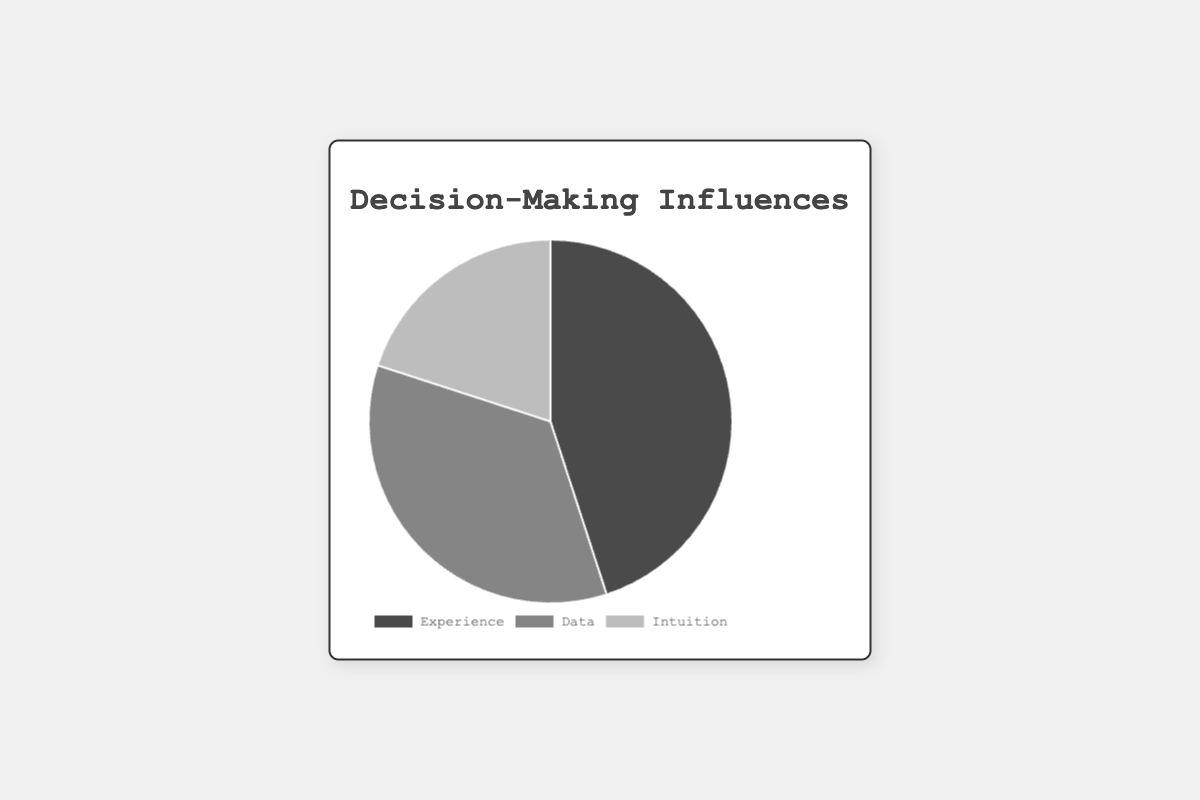What percentage of decision-making is influenced by intuition? The pie chart shows that the "Intuition" slice occupies 20% of the pie chart.
Answer: 20% Which influence has the largest proportion in decision-making? By looking at the proportions in the pie chart, "Experience" has the largest slice, indicating it has the largest proportion at 45%.
Answer: Experience How much more does experience influence decision-making compared to data? "Experience" influences decision-making by 45%, while "Data" influences it by 35%. The difference can be calculated as 45% - 35% = 10%.
Answer: 10% Which category influences decision-making the least? The smallest slice in the pie chart represents the "Intuition" category, which occupies 20% of the chart.
Answer: Intuition Is the proportion of decisions influenced by data more than double the proportion influenced by intuition? The proportion of intuition is 20%, and twice that is 40%. The data influence is 35%, which is less than 40%, so it’s not more than double.
Answer: No What are the combined percentages of experience and intuition influences? Adding the percentages of "Experience" (45%) and "Intuition" (20%) results in 45% + 20% = 65%.
Answer: 65% How much more do experience and data combined influence decision-making compared to intuition? The combined percentage of "Experience" and "Data" is 45% + 35% = 80%. The difference between this combined influence and "Intuition" (20%) is 80% - 20% = 60%.
Answer: 60% What is the difference between the highest and lowest influences on decision-making? The highest influence is "Experience" at 45% and the lowest is "Intuition" at 20%. The difference is 45% - 20% = 25%.
Answer: 25% Which color is used to represent the data-driven decision-making influence? The slice representing "Data" is depicted in a greyish color, which is visually lighter than the slices for "Experience" and "Intuition".
Answer: Grey If the data influences were to increase by 10%, what would the new percentage be? Adding 10% to the current data influence of 35% results in a new influence of 35% + 10% = 45%.
Answer: 45% 